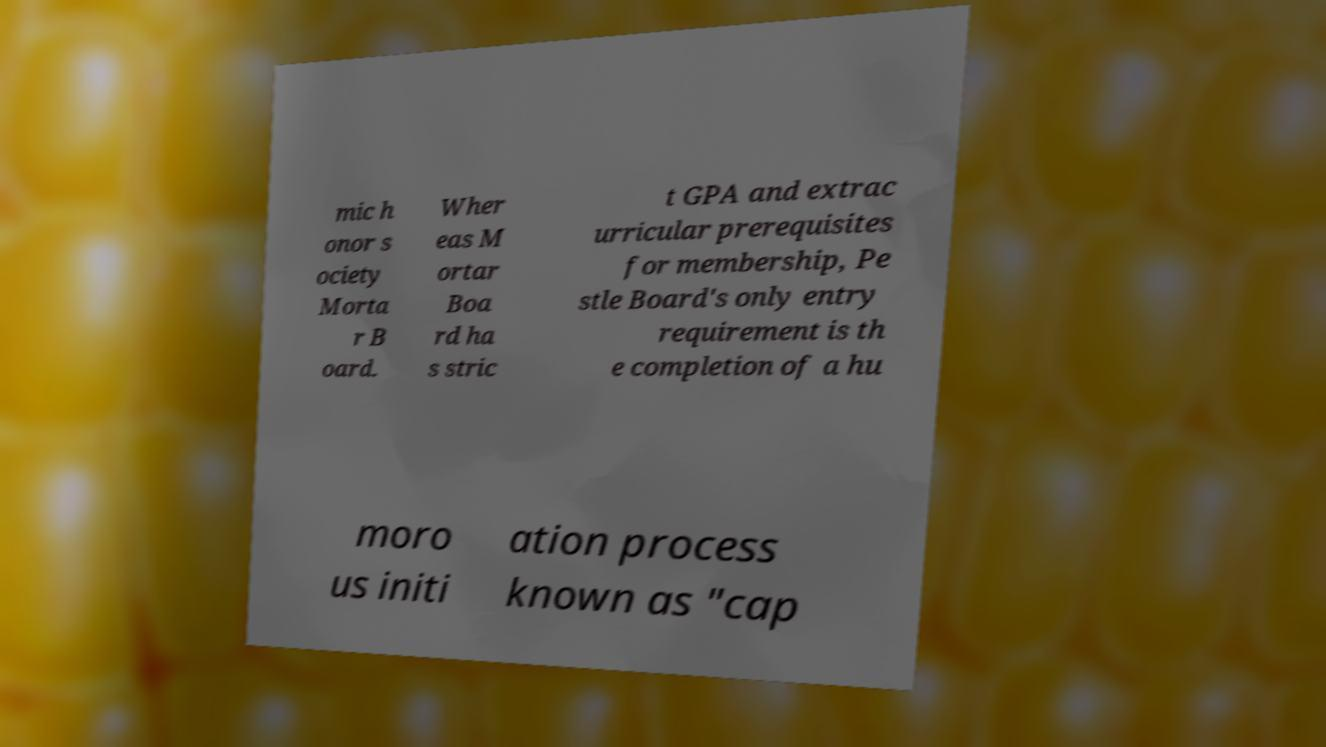Could you extract and type out the text from this image? mic h onor s ociety Morta r B oard. Wher eas M ortar Boa rd ha s stric t GPA and extrac urricular prerequisites for membership, Pe stle Board's only entry requirement is th e completion of a hu moro us initi ation process known as "cap 